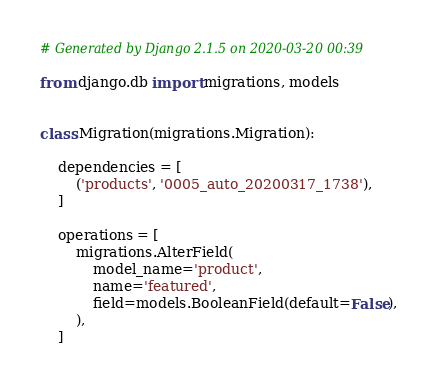<code> <loc_0><loc_0><loc_500><loc_500><_Python_># Generated by Django 2.1.5 on 2020-03-20 00:39

from django.db import migrations, models


class Migration(migrations.Migration):

    dependencies = [
        ('products', '0005_auto_20200317_1738'),
    ]

    operations = [
        migrations.AlterField(
            model_name='product',
            name='featured',
            field=models.BooleanField(default=False),
        ),
    ]
</code> 